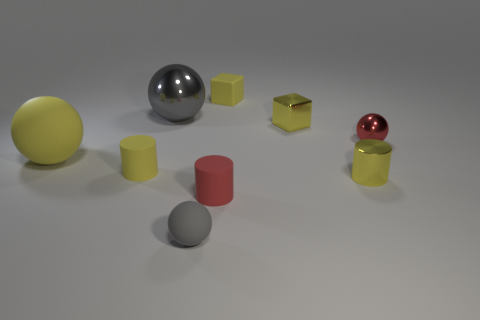What is the shape of the big object that is the same color as the tiny shiny cylinder?
Offer a terse response. Sphere. How many small brown metal cylinders are there?
Your response must be concise. 0. What number of things are tiny red matte cylinders or cubes?
Offer a terse response. 3. What is the size of the ball that is the same color as the small metal cube?
Keep it short and to the point. Large. There is a large shiny sphere; are there any matte spheres in front of it?
Give a very brief answer. Yes. Are there more small red things that are in front of the tiny red metallic ball than small red objects left of the large yellow ball?
Offer a very short reply. Yes. There is another rubber object that is the same shape as the big yellow object; what is its size?
Provide a short and direct response. Small. What number of blocks are either large gray metallic things or small red objects?
Make the answer very short. 0. There is another block that is the same color as the metal block; what is its material?
Give a very brief answer. Rubber. Are there fewer big yellow spheres that are in front of the tiny yellow metallic cube than small cylinders to the right of the large metal ball?
Offer a very short reply. Yes. 